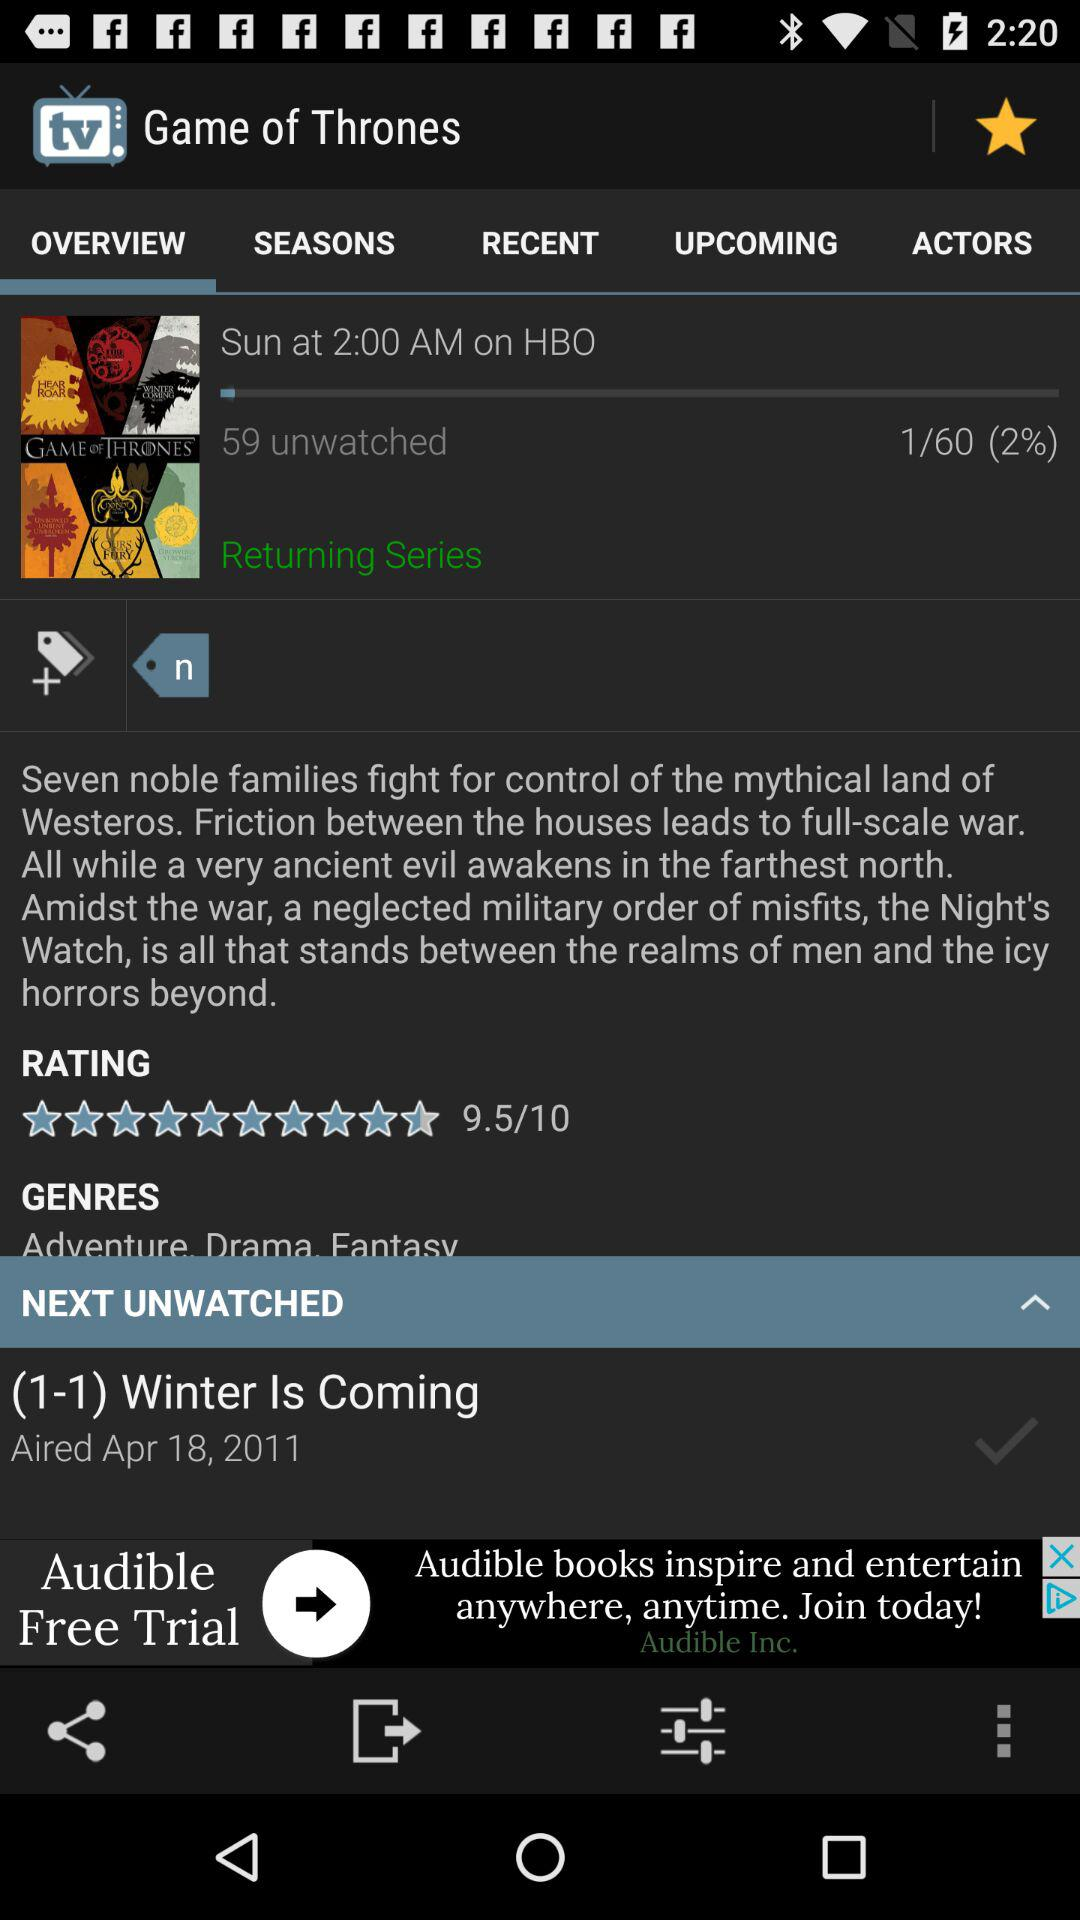How many unwatched episodes of Game of Thrones are there?
Answer the question using a single word or phrase. 59 